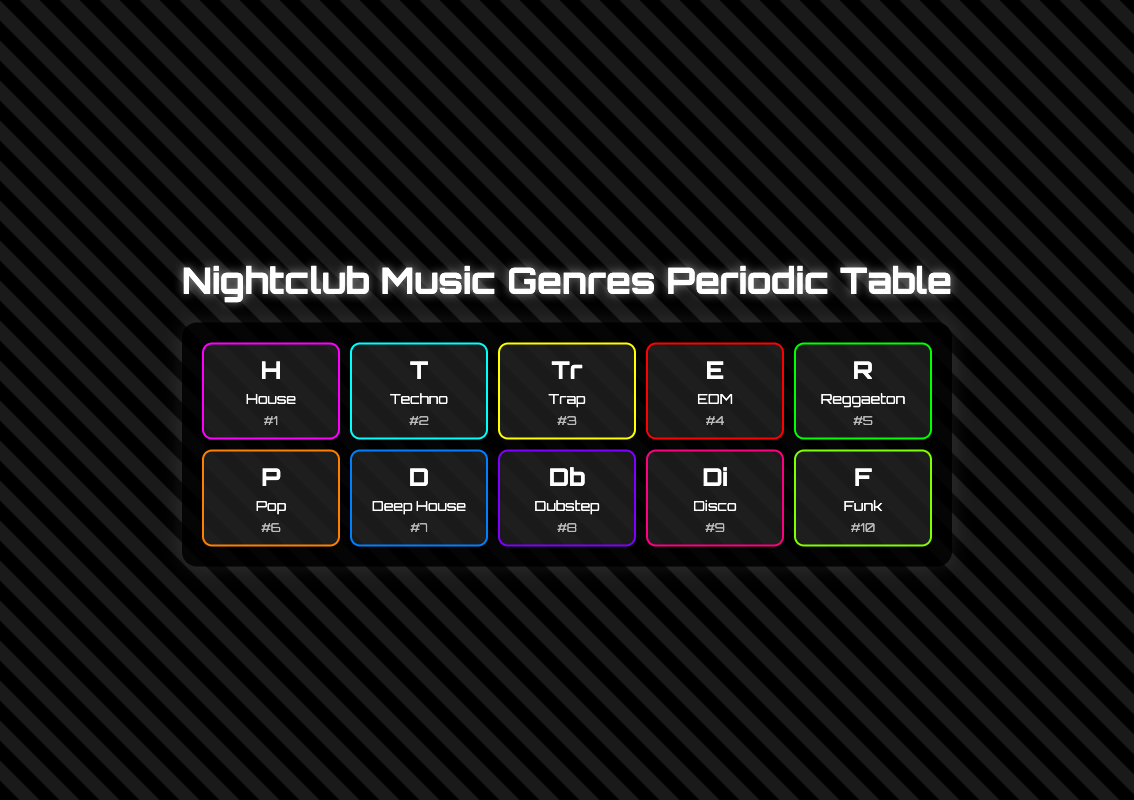What is the most popular music genre in nightclubs from 2021 to 2023? The table indicates that "House" is ranked #1 in popularity among the music genres in nightclubs.
Answer: House What are the notable artists associated with Reggaeton? From the table, the notable artists listed for Reggaeton are Bad Bunny, J Balvin, and Daddy Yankee.
Answer: Bad Bunny, J Balvin, Daddy Yankee Which genre is ranked 4th and what are its key characteristics? The 4th ranked genre is "EDM," with key characteristics including build-ups, drops, and festival anthems as stated in the table.
Answer: EDM, Build-ups, Drops, Festival anthems How many genres have a popularity rank higher than 5? By reviewing the ranks in the table, the genres ranked higher than 5 are House, Techno, Trap, EDM, and Reggaeton. That totals 5 genres.
Answer: 5 Is Dubstep one of the top three music genres in nightclubs? The table lists Dubstep at the 8th rank, which is below the top three ranks. Thus, the answer is no.
Answer: No What common characteristics are shared by House and Deep House? Upon examining the table, both genres emphasize melodic elements—House with melodic basslines and Deep House with warm bass, suggesting a connection in their sound design.
Answer: Similar melodic elements What is the difference in popularity rank between Techno and Pop? Techno is ranked 2nd and Pop is ranked 6th; taking the difference: 6 - 2 = 4.
Answer: 4 Which genre has a descriptive focus on brass instruments? The table indicates that "Funk" emphasizes rhythm and groove, with the use of brass instruments as part of its sound profile.
Answer: Funk Is the average popularity rank of the genres Trap and Dubstep higher than 6? The ranks for Trap (3) and Dubstep (8) sum to 3 + 8 = 11, and the average is 11 / 2 = 5.5, which is not higher than 6.
Answer: No 